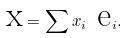<formula> <loc_0><loc_0><loc_500><loc_500>\text { x} = \sum x _ { i } \text { e} _ { i } .</formula> 